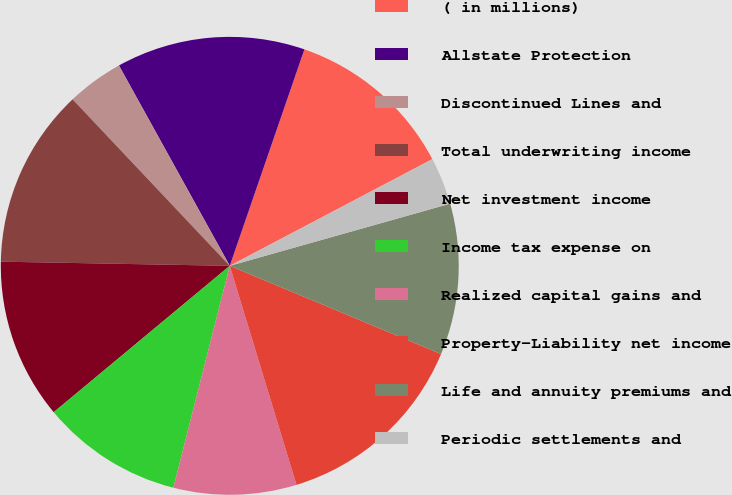Convert chart. <chart><loc_0><loc_0><loc_500><loc_500><pie_chart><fcel>( in millions)<fcel>Allstate Protection<fcel>Discontinued Lines and<fcel>Total underwriting income<fcel>Net investment income<fcel>Income tax expense on<fcel>Realized capital gains and<fcel>Property-Liability net income<fcel>Life and annuity premiums and<fcel>Periodic settlements and<nl><fcel>12.0%<fcel>13.33%<fcel>4.0%<fcel>12.67%<fcel>11.33%<fcel>10.0%<fcel>8.67%<fcel>14.0%<fcel>10.67%<fcel>3.34%<nl></chart> 